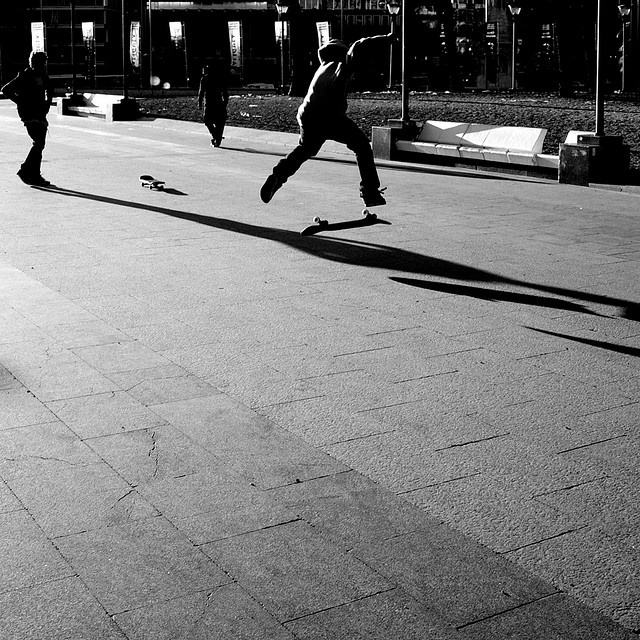Describe the objects in this image and their specific colors. I can see people in black, white, darkgray, and gray tones, bench in black, white, darkgray, and gray tones, people in black, lightgray, gray, and darkgray tones, people in black, gray, darkgray, and gainsboro tones, and bench in black, white, gray, and darkgray tones in this image. 